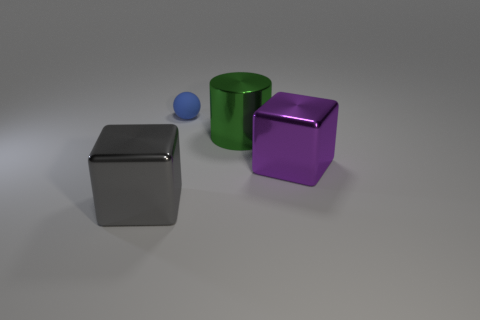What number of things are left of the tiny ball and behind the large gray thing?
Your answer should be very brief. 0. There is a block in front of the big block that is on the right side of the object left of the blue rubber ball; what is its material?
Offer a very short reply. Metal. How many large gray cubes are the same material as the green cylinder?
Offer a very short reply. 1. There is a purple shiny object that is the same size as the green object; what shape is it?
Make the answer very short. Cube. There is a large green cylinder; are there any big green metal cylinders behind it?
Your response must be concise. No. Are there any purple shiny objects of the same shape as the big green thing?
Offer a terse response. No. There is a large metallic object to the left of the rubber thing; does it have the same shape as the big thing that is behind the purple metal thing?
Give a very brief answer. No. Are there any gray metallic objects of the same size as the green object?
Give a very brief answer. Yes. Are there an equal number of small matte things on the right side of the green metallic cylinder and gray cubes on the right side of the purple object?
Ensure brevity in your answer.  Yes. Do the block that is behind the gray thing and the blue object that is behind the big green metallic thing have the same material?
Your answer should be very brief. No. 